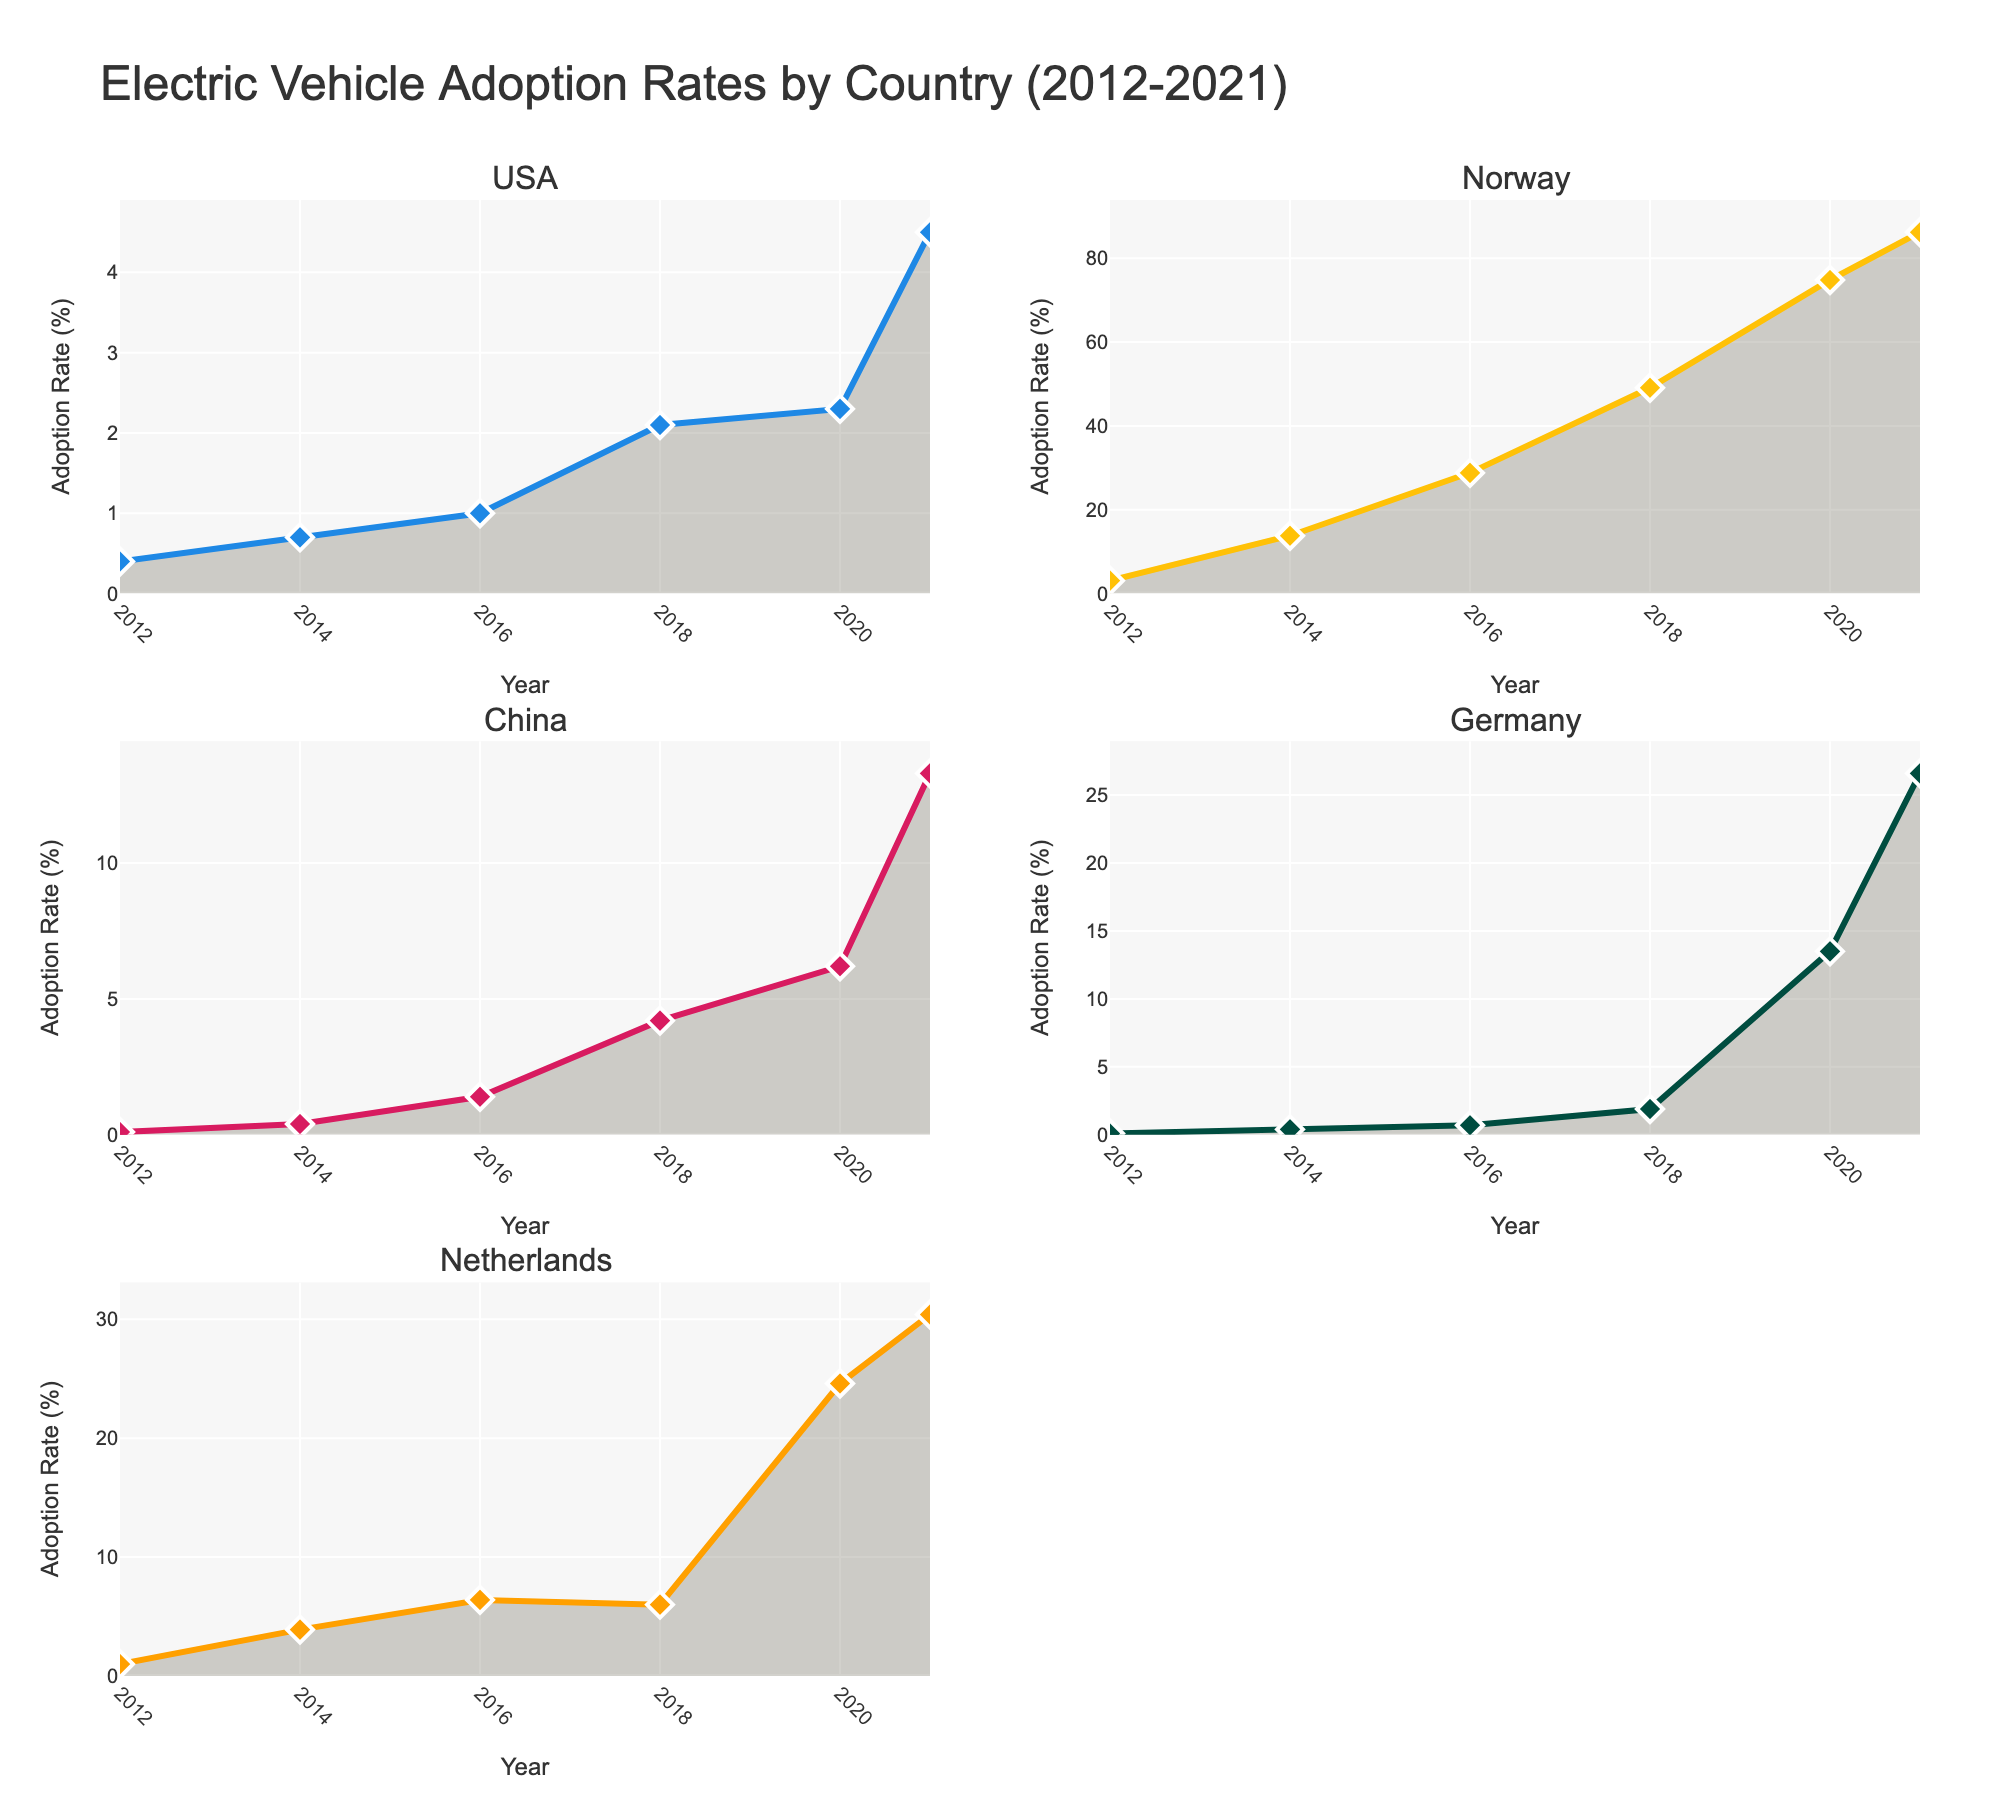What is the title of the figure? The title of the figure is displayed prominently at the top. It captures the overall subject of the visual data.
Answer: Electric Vehicle Adoption Rates by Country (2012-2021) How many subplots are there in the figure? There are separate visual components within the main figure, each representing a different set of data. By counting these, we can determine the number of subplots.
Answer: 5 Which country had the highest adoption rate in 2021? Look at the marker or peak on the line graph for the year 2021 in each subplot. Identify the subplot with the highest value.
Answer: Norway What is the adoption rate of electric vehicles in the USA in 2018? Locate the USA subplot. Find the data point for the year 2018 and note the adoption rate.
Answer: 2.1% Which country showed the most significant increase in adoption rates from 2012 to 2021? Compare the values from 2012 to 2021 for each country. Calculate the difference for each and identify the country with the highest increase.
Answer: Norway What is the average adoption rate of electric vehicles in the Netherlands from 2012 to 2021? Locate the data points in the Netherlands subplot. Sum these values and divide by the number of data points (6 years).
Answer: 12.05% How does the adoption rate in China in 2021 compare to Germany in 2018? Locate the adoption rate for China in 2021 and Germany in 2018 from their respective subplots. Compare these values directly.
Answer: Higher in China Which two countries had adoption rates of electric vehicles below 1% in 2014? Review all subplots for the year 2014 and identify countries with rates below 1%.
Answer: USA and China What trend do you observe in Germany's adoption rates from 2016 to 2021? Examine Germany's subplot from 2016 to 2021 and describe whether the adoption rate increases, decreases, or remains stable.
Answer: Increasing What color represents the adoption rate for the Netherlands? Identify the color used to plot the Netherlands data by looking at the legend or directly at the subplot.
Answer: Orange 